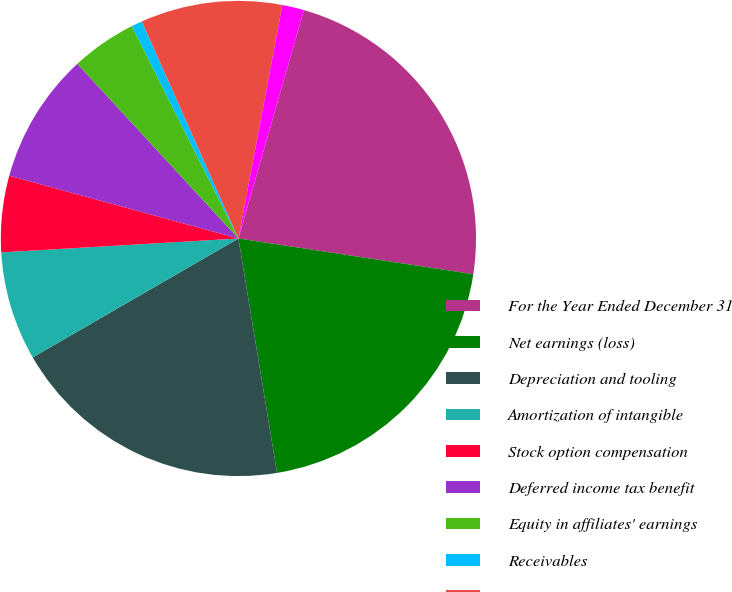<chart> <loc_0><loc_0><loc_500><loc_500><pie_chart><fcel>For the Year Ended December 31<fcel>Net earnings (loss)<fcel>Depreciation and tooling<fcel>Amortization of intangible<fcel>Stock option compensation<fcel>Deferred income tax benefit<fcel>Equity in affiliates' earnings<fcel>Receivables<fcel>Inventories<fcel>Prepayments and other current<nl><fcel>22.96%<fcel>20.0%<fcel>19.26%<fcel>7.41%<fcel>5.19%<fcel>8.89%<fcel>4.45%<fcel>0.74%<fcel>9.63%<fcel>1.48%<nl></chart> 